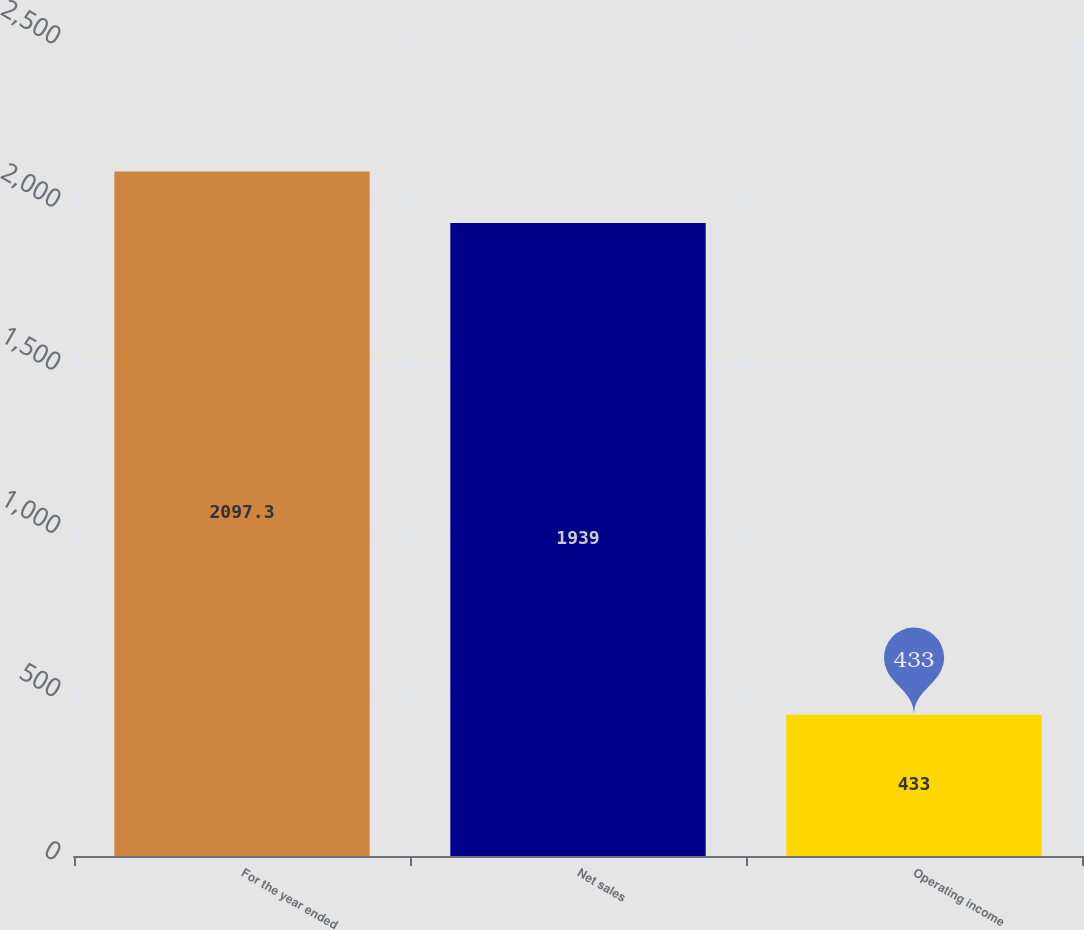Convert chart. <chart><loc_0><loc_0><loc_500><loc_500><bar_chart><fcel>For the year ended<fcel>Net sales<fcel>Operating income<nl><fcel>2097.3<fcel>1939<fcel>433<nl></chart> 